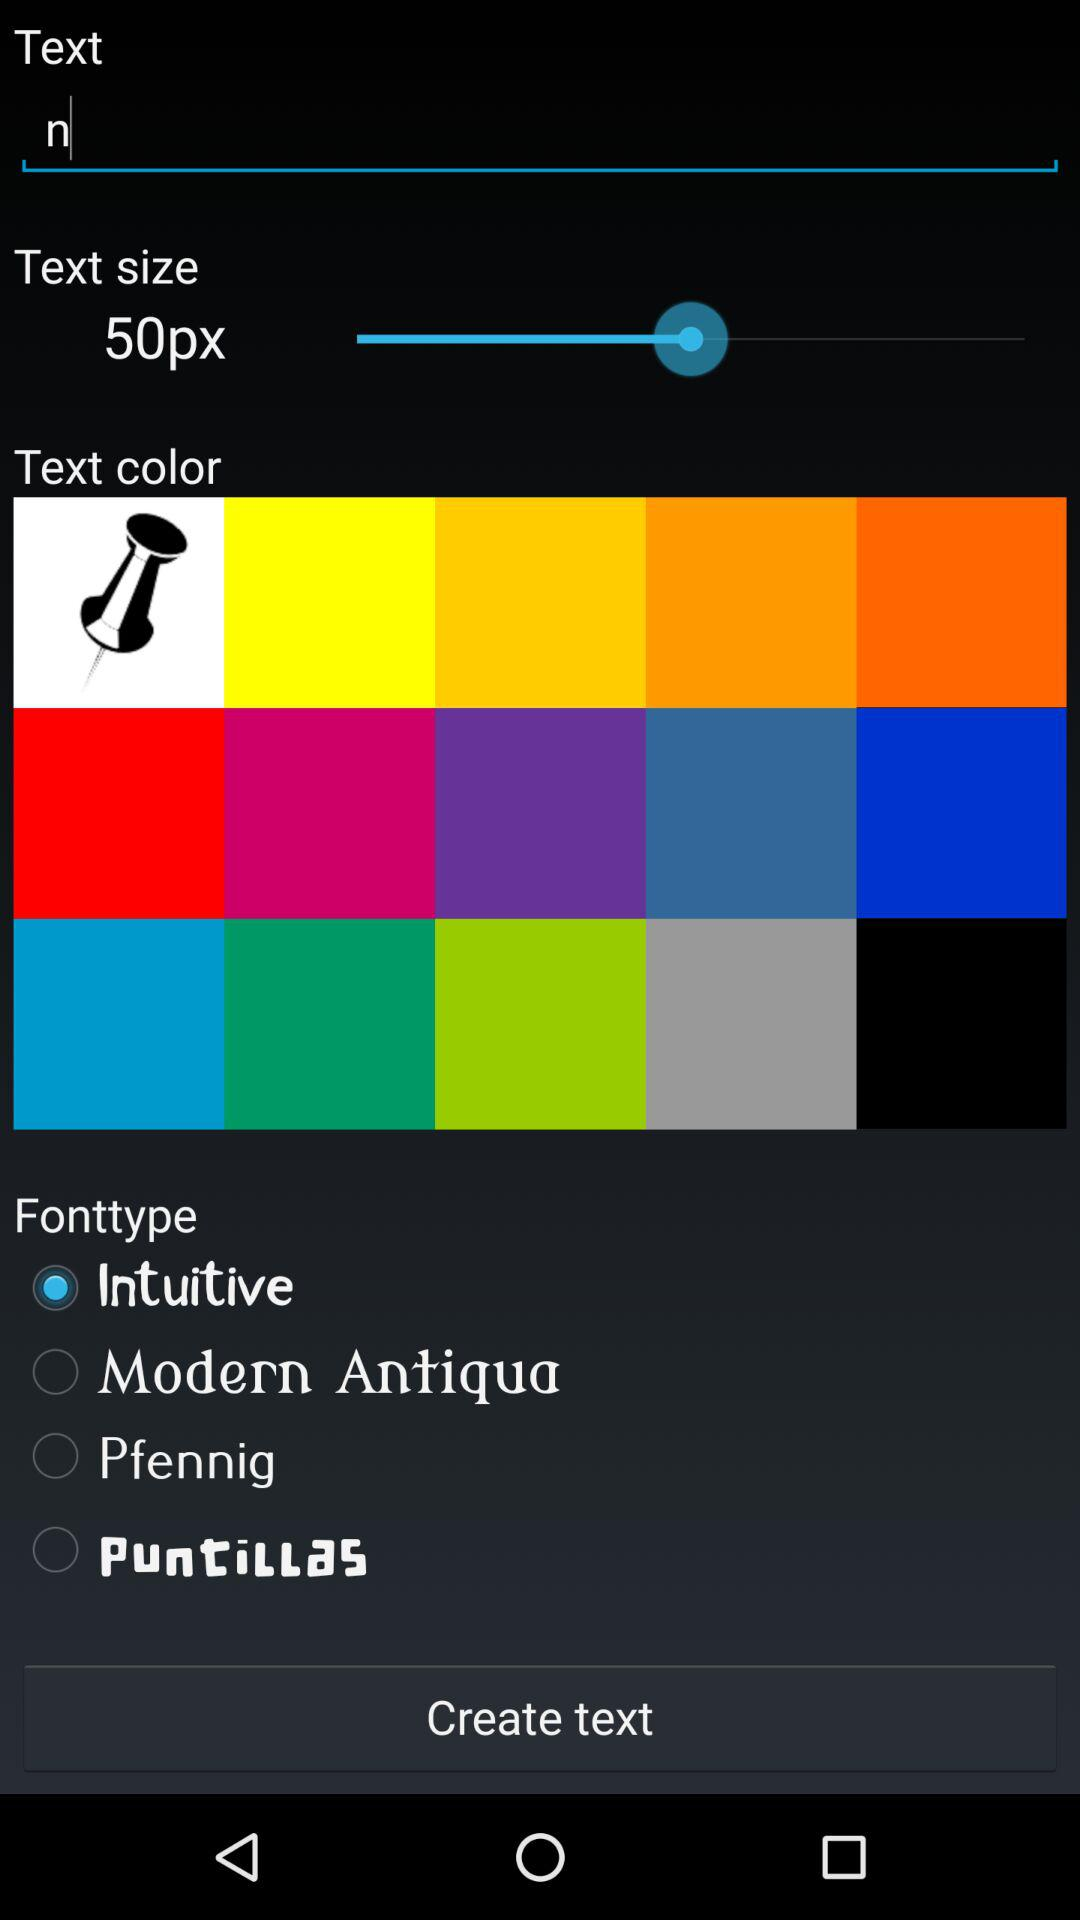What is the selected font type? The selected font type is "Intuitive". 